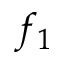Convert formula to latex. <formula><loc_0><loc_0><loc_500><loc_500>f _ { 1 }</formula> 